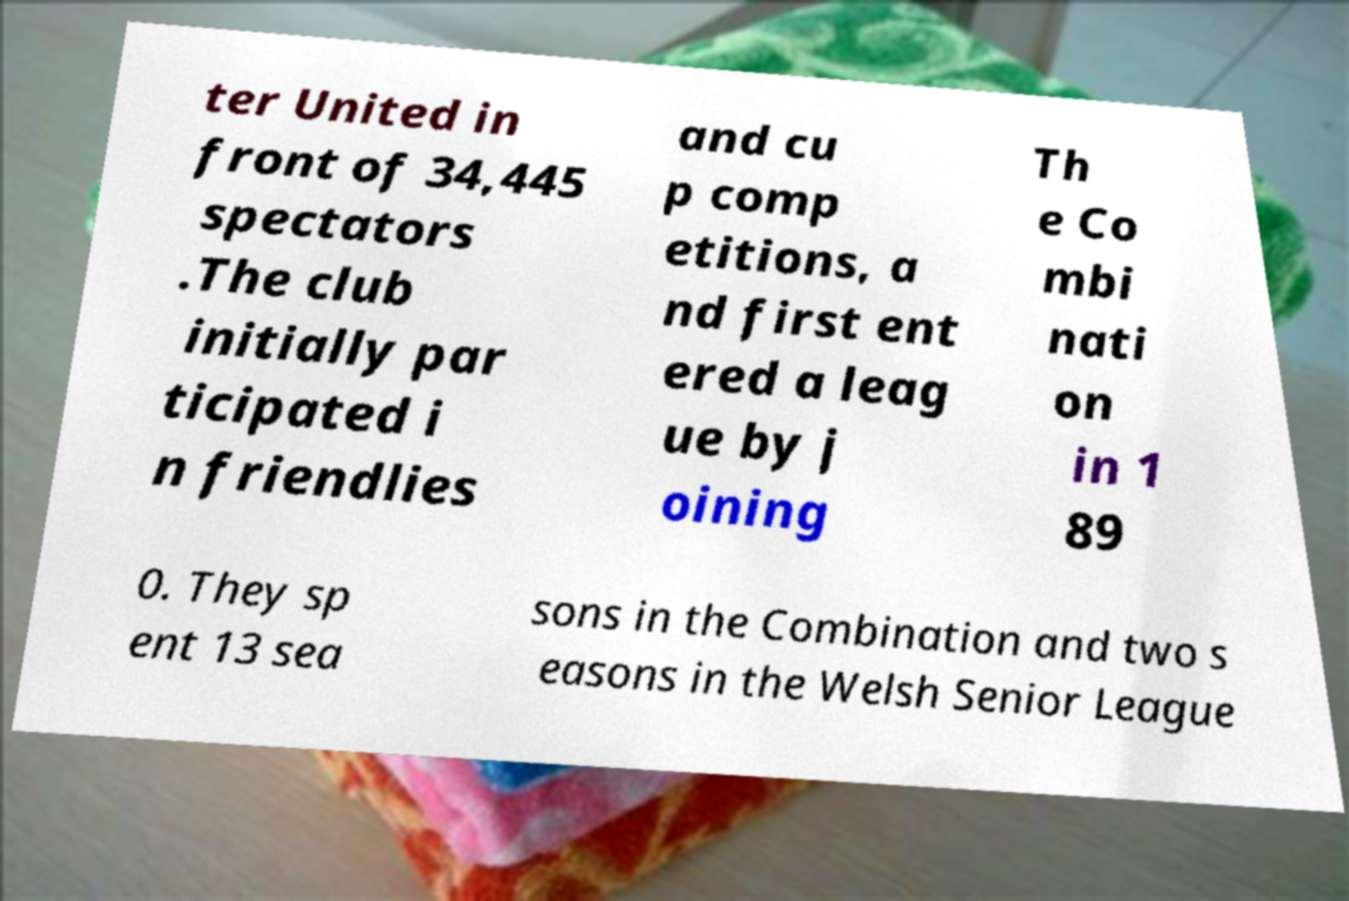I need the written content from this picture converted into text. Can you do that? ter United in front of 34,445 spectators .The club initially par ticipated i n friendlies and cu p comp etitions, a nd first ent ered a leag ue by j oining Th e Co mbi nati on in 1 89 0. They sp ent 13 sea sons in the Combination and two s easons in the Welsh Senior League 